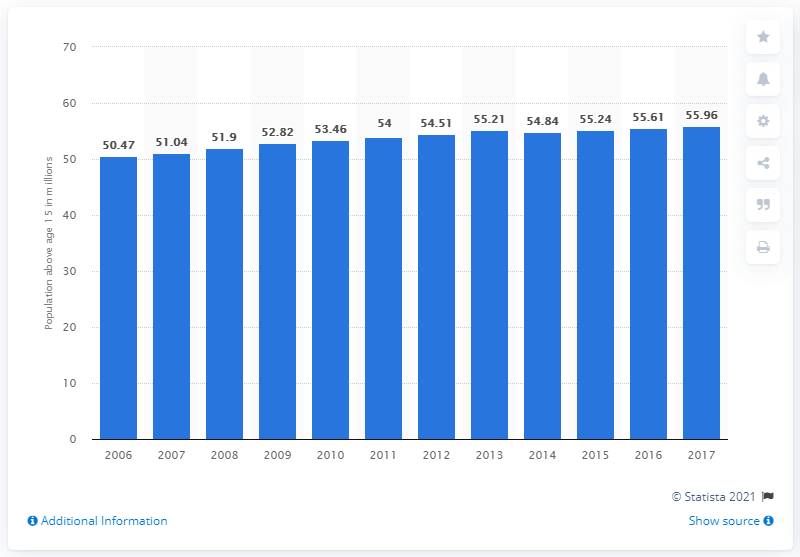Highlight a few significant elements in this photo. In 2017, the working-age population in Thailand was 55.96. 